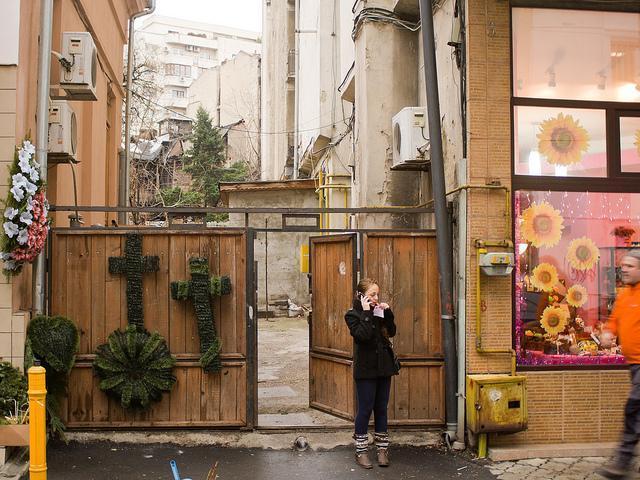How many people are there?
Give a very brief answer. 1. How many people can be seen?
Give a very brief answer. 2. 